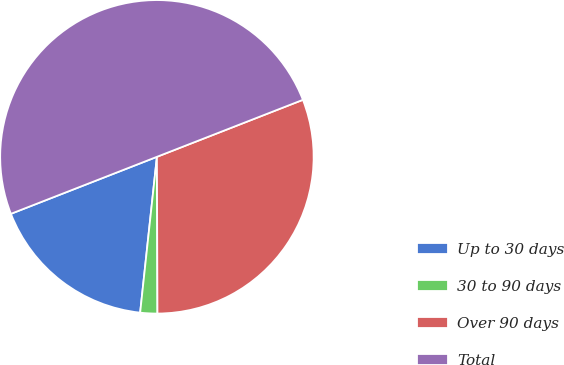<chart> <loc_0><loc_0><loc_500><loc_500><pie_chart><fcel>Up to 30 days<fcel>30 to 90 days<fcel>Over 90 days<fcel>Total<nl><fcel>17.37%<fcel>1.76%<fcel>30.87%<fcel>50.0%<nl></chart> 